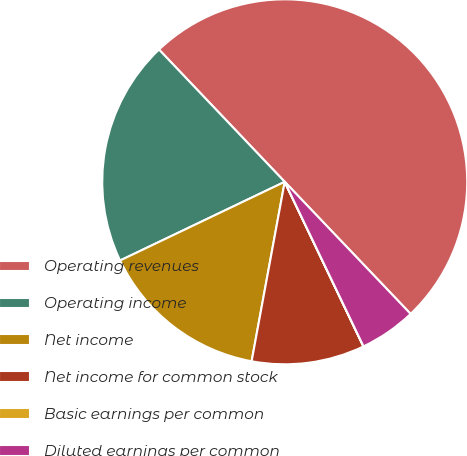Convert chart to OTSL. <chart><loc_0><loc_0><loc_500><loc_500><pie_chart><fcel>Operating revenues<fcel>Operating income<fcel>Net income<fcel>Net income for common stock<fcel>Basic earnings per common<fcel>Diluted earnings per common<nl><fcel>49.98%<fcel>20.0%<fcel>15.0%<fcel>10.0%<fcel>0.01%<fcel>5.01%<nl></chart> 